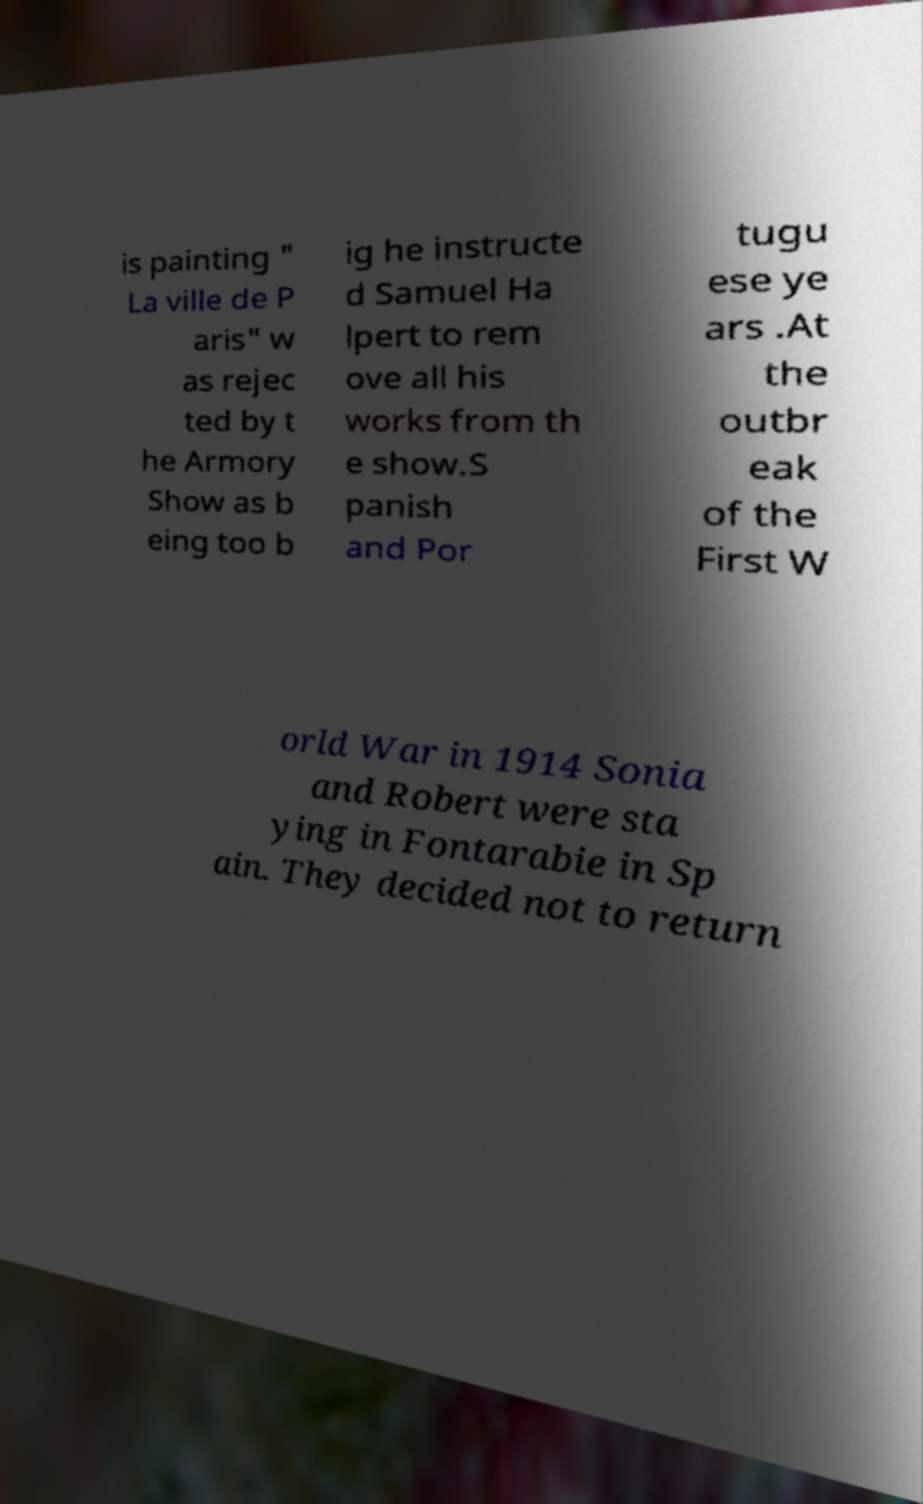I need the written content from this picture converted into text. Can you do that? is painting " La ville de P aris" w as rejec ted by t he Armory Show as b eing too b ig he instructe d Samuel Ha lpert to rem ove all his works from th e show.S panish and Por tugu ese ye ars .At the outbr eak of the First W orld War in 1914 Sonia and Robert were sta ying in Fontarabie in Sp ain. They decided not to return 